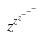<formula> <loc_0><loc_0><loc_500><loc_500>z ^ { z ^ { z ^ { - ^ { - ^ { - } } } } }</formula> 